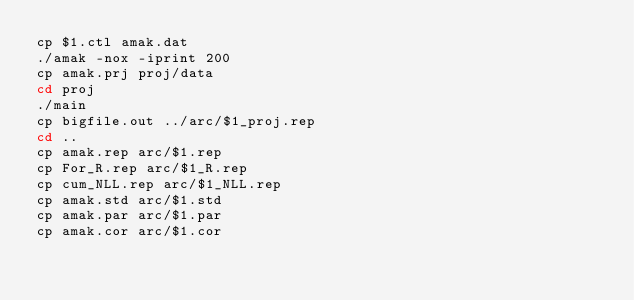<code> <loc_0><loc_0><loc_500><loc_500><_Bash_>cp $1.ctl amak.dat
./amak -nox -iprint 200
cp amak.prj proj/data
cd proj
./main
cp bigfile.out ../arc/$1_proj.rep
cd ..
cp amak.rep arc/$1.rep
cp For_R.rep arc/$1_R.rep
cp cum_NLL.rep arc/$1_NLL.rep
cp amak.std arc/$1.std
cp amak.par arc/$1.par
cp amak.cor arc/$1.cor
</code> 